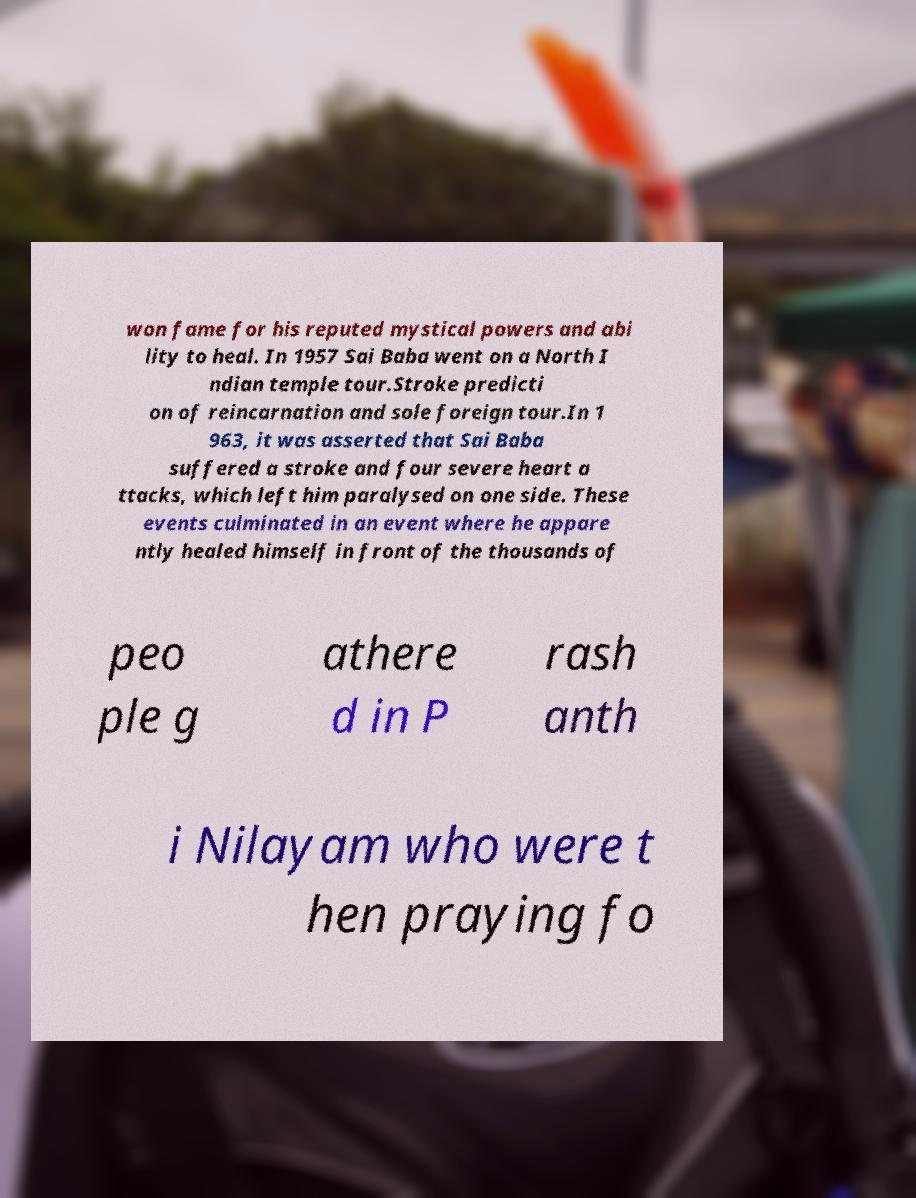Can you accurately transcribe the text from the provided image for me? won fame for his reputed mystical powers and abi lity to heal. In 1957 Sai Baba went on a North I ndian temple tour.Stroke predicti on of reincarnation and sole foreign tour.In 1 963, it was asserted that Sai Baba suffered a stroke and four severe heart a ttacks, which left him paralysed on one side. These events culminated in an event where he appare ntly healed himself in front of the thousands of peo ple g athere d in P rash anth i Nilayam who were t hen praying fo 